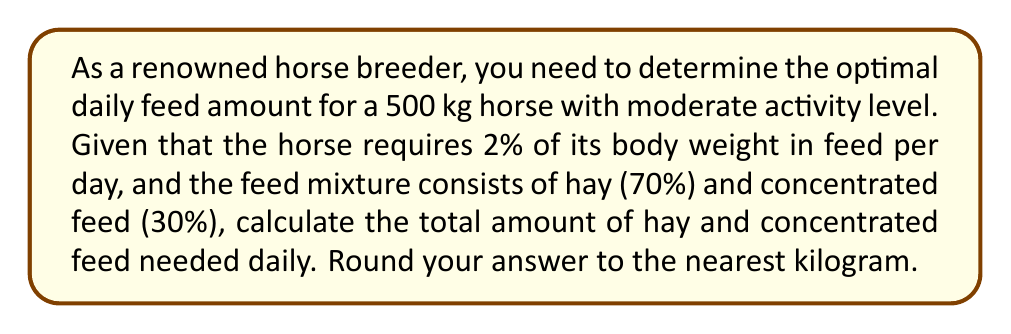Could you help me with this problem? Let's break this down step-by-step:

1. Calculate the total daily feed requirement:
   $$ \text{Total feed} = \text{Horse weight} \times \text{Feed percentage} $$
   $$ \text{Total feed} = 500 \text{ kg} \times 0.02 = 10 \text{ kg} $$

2. Calculate the amount of hay (70% of total feed):
   $$ \text{Hay amount} = \text{Total feed} \times \text{Hay percentage} $$
   $$ \text{Hay amount} = 10 \text{ kg} \times 0.70 = 7 \text{ kg} $$

3. Calculate the amount of concentrated feed (30% of total feed):
   $$ \text{Concentrated feed} = \text{Total feed} \times \text{Concentrated feed percentage} $$
   $$ \text{Concentrated feed} = 10 \text{ kg} \times 0.30 = 3 \text{ kg} $$

4. Round the results to the nearest kilogram:
   Hay: 7 kg
   Concentrated feed: 3 kg
Answer: 7 kg hay, 3 kg concentrated feed 